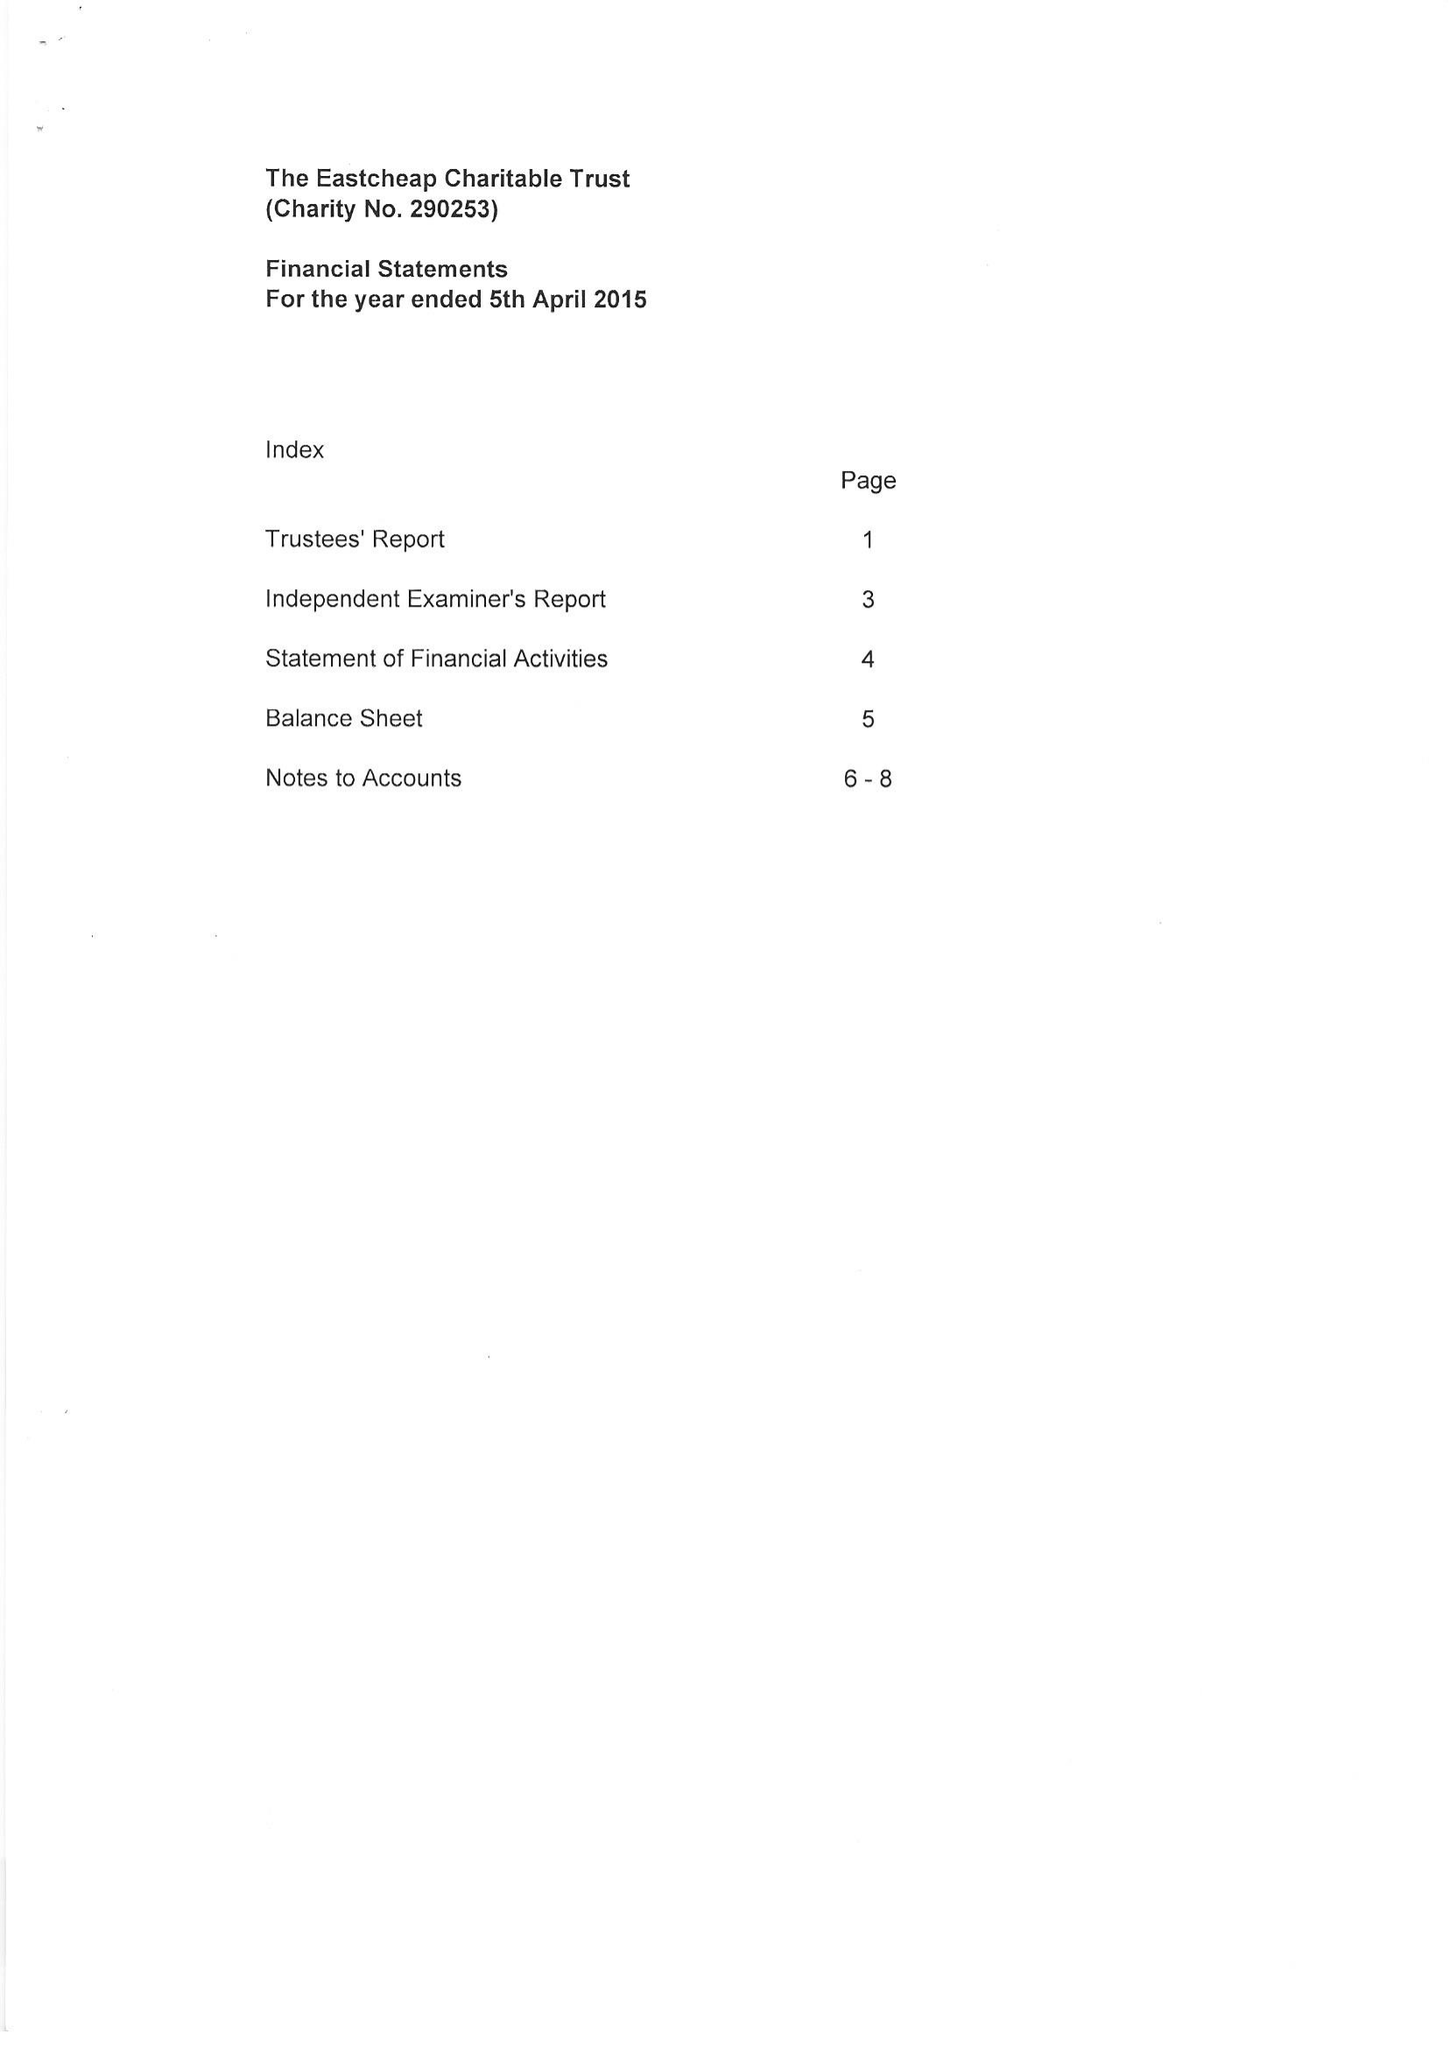What is the value for the address__post_town?
Answer the question using a single word or phrase. FARNHAM 